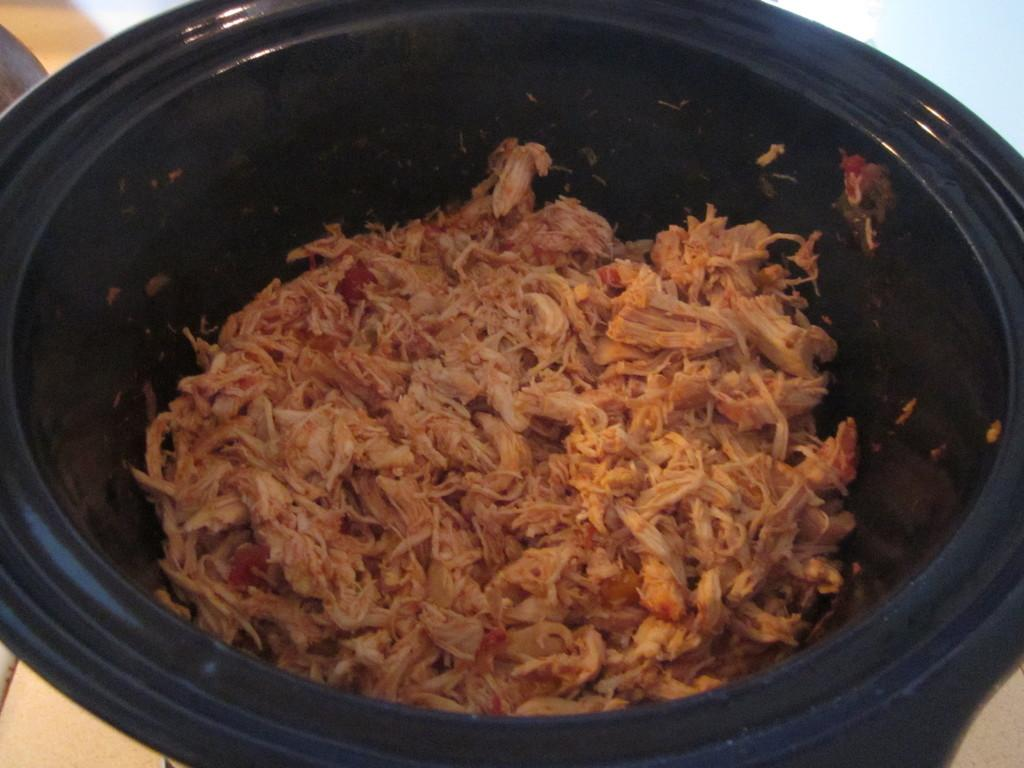What is in the bowl that is visible in the image? There is food in a bowl in the image. What type of thread is being used to create the moon in the image? There is no moon present in the image, and therefore no thread is being used to create it. 